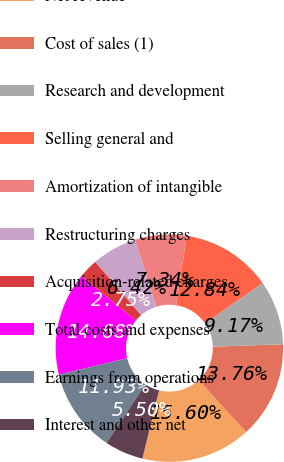Convert chart. <chart><loc_0><loc_0><loc_500><loc_500><pie_chart><fcel>Net revenue<fcel>Cost of sales (1)<fcel>Research and development<fcel>Selling general and<fcel>Amortization of intangible<fcel>Restructuring charges<fcel>Acquisition-related charges<fcel>Total costs and expenses<fcel>Earnings from operations<fcel>Interest and other net<nl><fcel>15.6%<fcel>13.76%<fcel>9.17%<fcel>12.84%<fcel>7.34%<fcel>6.42%<fcel>2.75%<fcel>14.68%<fcel>11.93%<fcel>5.5%<nl></chart> 